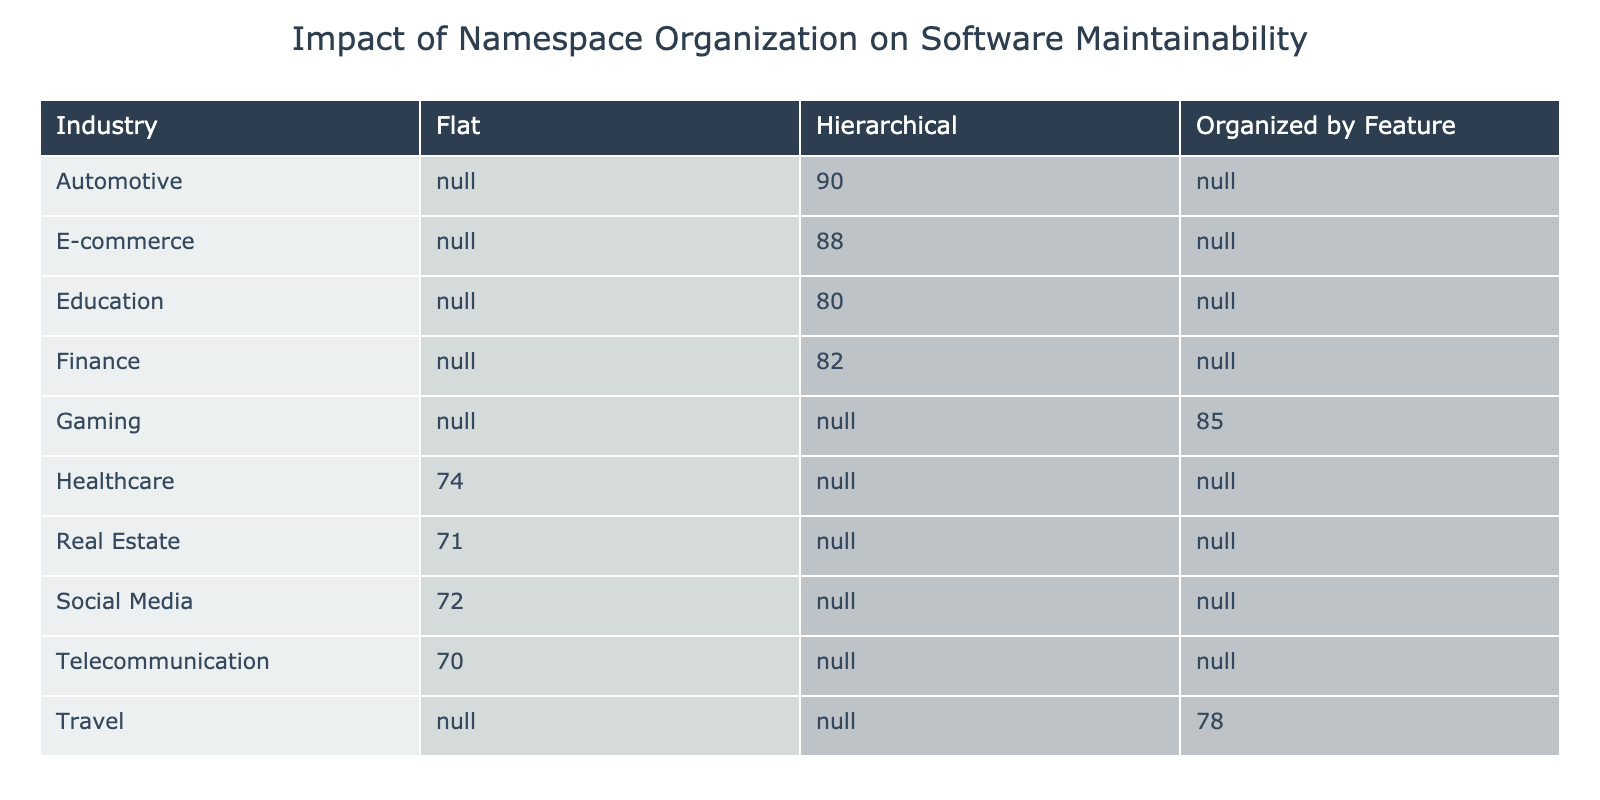What is the Average Maintainability Score for the Automotive industry using Hierarchical namespace organization? The table indicates that the Average Maintainability Score for the Automotive industry with Hierarchical namespace organization is directly listed as 90.
Answer: 90 Which industry has the Lowest Average Maintainability Score, and what is that score? By reviewing the Average Maintainability Scores in the table, the Real Estate industry has the lowest score of 71.
Answer: 71 How many projects in the E-commerce industry utilize Hierarchical namespace organization? The table shows that there are 75 projects in the E-commerce industry that make use of the Hierarchical namespace organization type.
Answer: 75 If we compare the Average Maintainability Scores of Flat and Organized by Feature namespace organizations, which type generally has a higher average score based on the table? The Average Maintainability Scores for Flat organization are 74, 70, and 72 (average = 72), while for Organized by Feature, the scores are 85 and 78 (average = 81.5). Therefore, Organized by Feature generally has a higher average score compared to Flat organization.
Answer: Yes, Organized by Feature has a higher average What is the difference between the Average Maintainability Score of Gaming and the Average Maintainability Score of Healthcare? The Average Maintainability Score for Gaming is 85 and for Healthcare is 74, thus the difference is 85 - 74 = 11.
Answer: 11 Is there an industry that has more projects than the Education industry while also using Hierarchical namespace organization? The Education industry has 20 projects. From the table, the Automotive industry has 25 projects with Hierarchical namespace organization. Hence the Automotive industry meets these criteria.
Answer: Yes What are the common issues encountered in the E-commerce industry? The table lists the common issue encountered in the E-commerce industry as "Namespace Conflicts."
Answer: Namespace Conflicts Which industry type among Hierarchical has the highest Average Maintainability Score and what is that score? In the Hierarchical category, the Automotive industry has the highest score listed at 90, making it the highest for that type.
Answer: 90 What are the Average Maintainability Scores for Flat namespace organization in Finance and Telecommunications? For Finance, the Average Maintainability Score is 74, and for Telecommunications, it is 70. Thus, the scores are 74 and 70 for these respective industries.
Answer: 74 and 70 